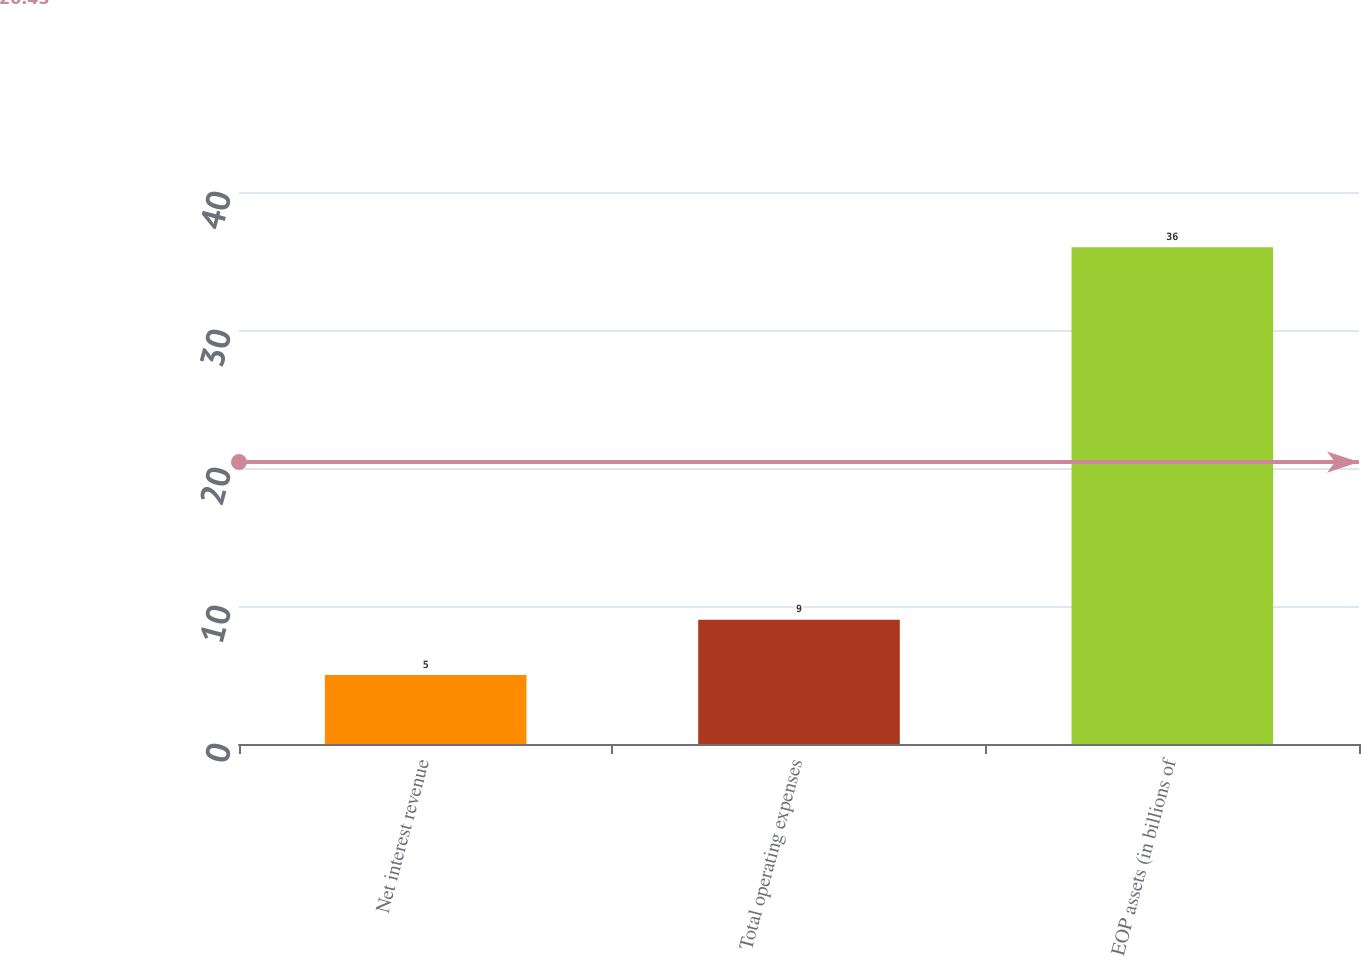Convert chart. <chart><loc_0><loc_0><loc_500><loc_500><bar_chart><fcel>Net interest revenue<fcel>Total operating expenses<fcel>EOP assets (in billions of<nl><fcel>5<fcel>9<fcel>36<nl></chart> 